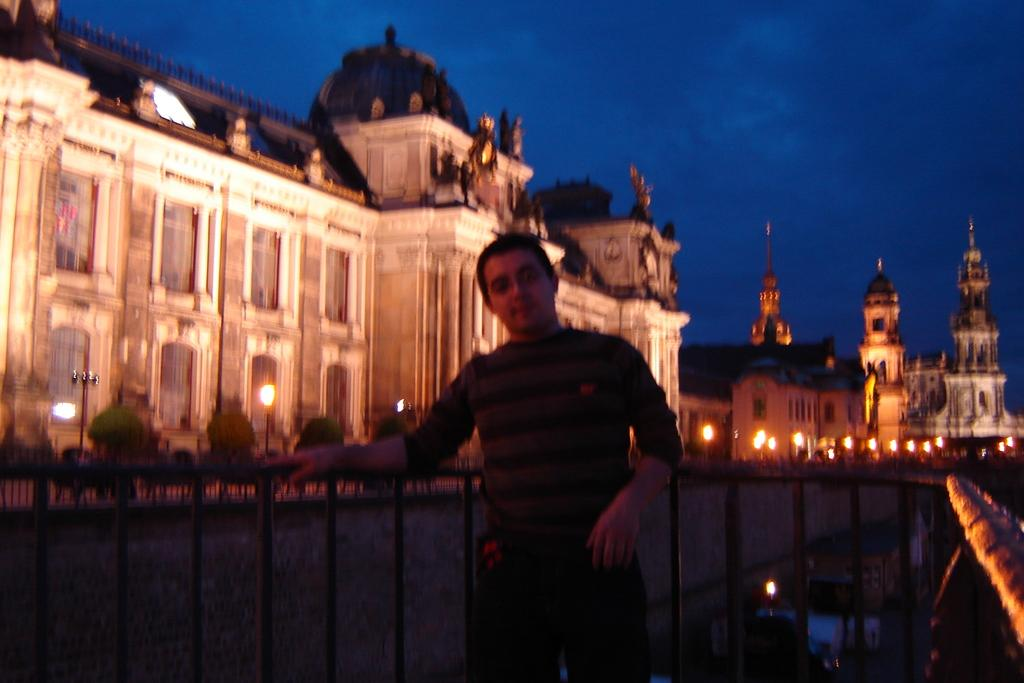What type of structures can be seen in the image? There are buildings in the image. What type of lighting is present in the image? Pole lights are visible in the image. What type of vegetation is present in the image? There are trees in the image. What is the gender of the person in the image? The person in the image is a man. What type of barrier is present in the image? There is a metal fence in the image. What color is the sky in the image? The sky is blue in the image. What type of territory is being claimed by the bomb in the image? There is no bomb present in the image, so no territory is being claimed. What type of attraction is the man visiting in the image? The image does not provide enough information to determine if the man is visiting any specific attraction. 